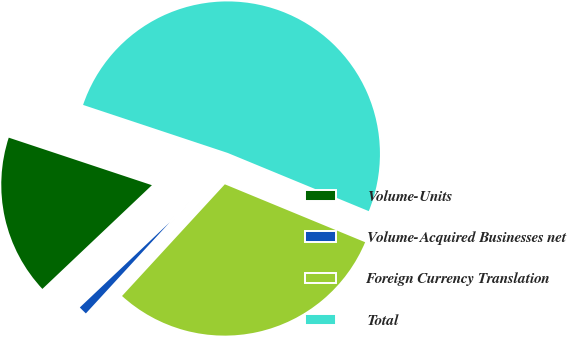<chart> <loc_0><loc_0><loc_500><loc_500><pie_chart><fcel>Volume-Units<fcel>Volume-Acquired Businesses net<fcel>Foreign Currency Translation<fcel>Total<nl><fcel>17.17%<fcel>1.09%<fcel>30.61%<fcel>51.12%<nl></chart> 